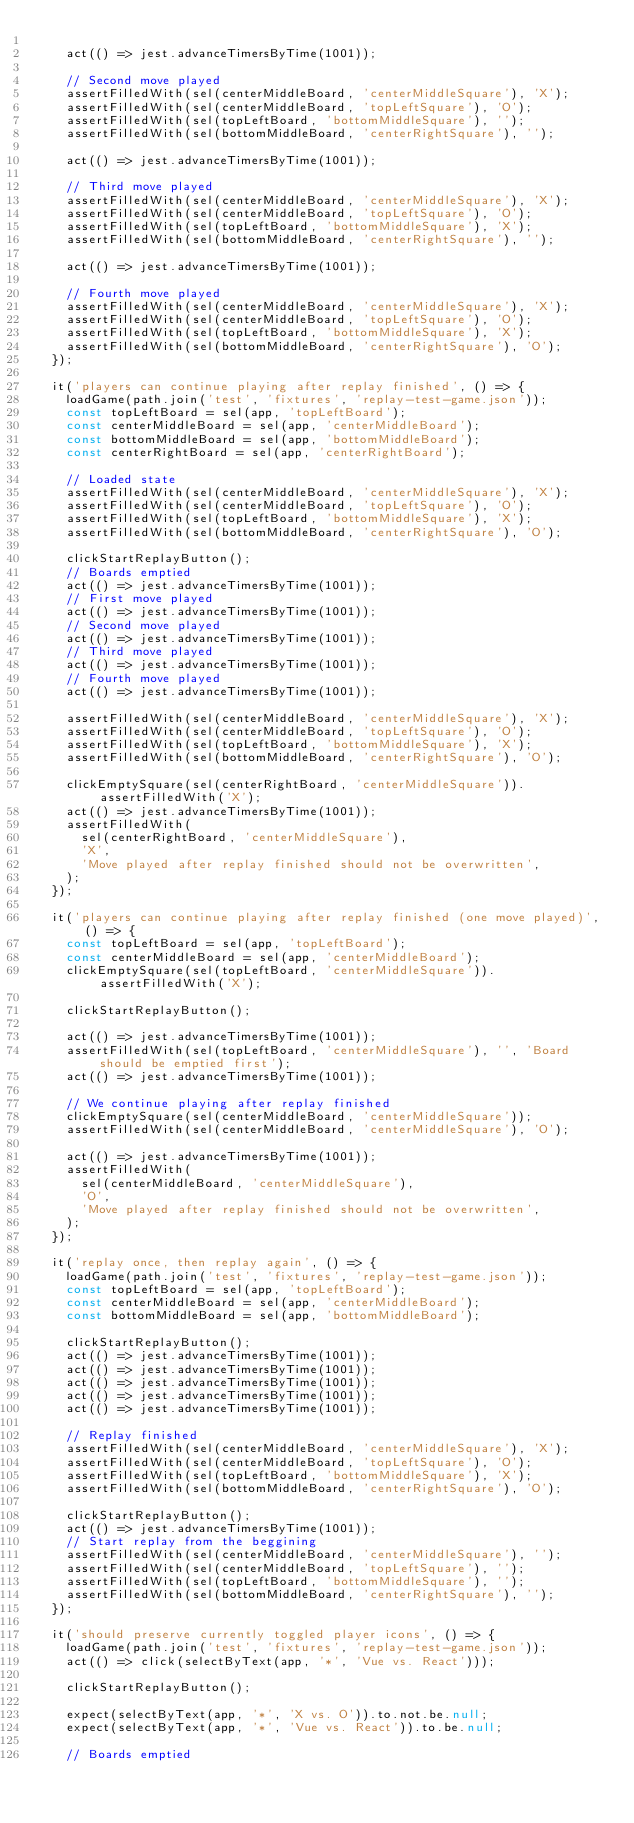<code> <loc_0><loc_0><loc_500><loc_500><_JavaScript_>
    act(() => jest.advanceTimersByTime(1001));

    // Second move played
    assertFilledWith(sel(centerMiddleBoard, 'centerMiddleSquare'), 'X');
    assertFilledWith(sel(centerMiddleBoard, 'topLeftSquare'), 'O');
    assertFilledWith(sel(topLeftBoard, 'bottomMiddleSquare'), '');
    assertFilledWith(sel(bottomMiddleBoard, 'centerRightSquare'), '');

    act(() => jest.advanceTimersByTime(1001));

    // Third move played
    assertFilledWith(sel(centerMiddleBoard, 'centerMiddleSquare'), 'X');
    assertFilledWith(sel(centerMiddleBoard, 'topLeftSquare'), 'O');
    assertFilledWith(sel(topLeftBoard, 'bottomMiddleSquare'), 'X');
    assertFilledWith(sel(bottomMiddleBoard, 'centerRightSquare'), '');

    act(() => jest.advanceTimersByTime(1001));

    // Fourth move played
    assertFilledWith(sel(centerMiddleBoard, 'centerMiddleSquare'), 'X');
    assertFilledWith(sel(centerMiddleBoard, 'topLeftSquare'), 'O');
    assertFilledWith(sel(topLeftBoard, 'bottomMiddleSquare'), 'X');
    assertFilledWith(sel(bottomMiddleBoard, 'centerRightSquare'), 'O');
  });

  it('players can continue playing after replay finished', () => {
    loadGame(path.join('test', 'fixtures', 'replay-test-game.json'));
    const topLeftBoard = sel(app, 'topLeftBoard');
    const centerMiddleBoard = sel(app, 'centerMiddleBoard');
    const bottomMiddleBoard = sel(app, 'bottomMiddleBoard');
    const centerRightBoard = sel(app, 'centerRightBoard');

    // Loaded state
    assertFilledWith(sel(centerMiddleBoard, 'centerMiddleSquare'), 'X');
    assertFilledWith(sel(centerMiddleBoard, 'topLeftSquare'), 'O');
    assertFilledWith(sel(topLeftBoard, 'bottomMiddleSquare'), 'X');
    assertFilledWith(sel(bottomMiddleBoard, 'centerRightSquare'), 'O');

    clickStartReplayButton();
    // Boards emptied
    act(() => jest.advanceTimersByTime(1001));
    // First move played
    act(() => jest.advanceTimersByTime(1001));
    // Second move played
    act(() => jest.advanceTimersByTime(1001));
    // Third move played
    act(() => jest.advanceTimersByTime(1001));
    // Fourth move played
    act(() => jest.advanceTimersByTime(1001));

    assertFilledWith(sel(centerMiddleBoard, 'centerMiddleSquare'), 'X');
    assertFilledWith(sel(centerMiddleBoard, 'topLeftSquare'), 'O');
    assertFilledWith(sel(topLeftBoard, 'bottomMiddleSquare'), 'X');
    assertFilledWith(sel(bottomMiddleBoard, 'centerRightSquare'), 'O');

    clickEmptySquare(sel(centerRightBoard, 'centerMiddleSquare')).assertFilledWith('X');
    act(() => jest.advanceTimersByTime(1001));
    assertFilledWith(
      sel(centerRightBoard, 'centerMiddleSquare'),
      'X',
      'Move played after replay finished should not be overwritten',
    );
  });

  it('players can continue playing after replay finished (one move played)', () => {
    const topLeftBoard = sel(app, 'topLeftBoard');
    const centerMiddleBoard = sel(app, 'centerMiddleBoard');
    clickEmptySquare(sel(topLeftBoard, 'centerMiddleSquare')).assertFilledWith('X');

    clickStartReplayButton();

    act(() => jest.advanceTimersByTime(1001));
    assertFilledWith(sel(topLeftBoard, 'centerMiddleSquare'), '', 'Board should be emptied first');
    act(() => jest.advanceTimersByTime(1001));

    // We continue playing after replay finished
    clickEmptySquare(sel(centerMiddleBoard, 'centerMiddleSquare'));
    assertFilledWith(sel(centerMiddleBoard, 'centerMiddleSquare'), 'O');

    act(() => jest.advanceTimersByTime(1001));
    assertFilledWith(
      sel(centerMiddleBoard, 'centerMiddleSquare'),
      'O',
      'Move played after replay finished should not be overwritten',
    );
  });

  it('replay once, then replay again', () => {
    loadGame(path.join('test', 'fixtures', 'replay-test-game.json'));
    const topLeftBoard = sel(app, 'topLeftBoard');
    const centerMiddleBoard = sel(app, 'centerMiddleBoard');
    const bottomMiddleBoard = sel(app, 'bottomMiddleBoard');

    clickStartReplayButton();
    act(() => jest.advanceTimersByTime(1001));
    act(() => jest.advanceTimersByTime(1001));
    act(() => jest.advanceTimersByTime(1001));
    act(() => jest.advanceTimersByTime(1001));
    act(() => jest.advanceTimersByTime(1001));

    // Replay finished
    assertFilledWith(sel(centerMiddleBoard, 'centerMiddleSquare'), 'X');
    assertFilledWith(sel(centerMiddleBoard, 'topLeftSquare'), 'O');
    assertFilledWith(sel(topLeftBoard, 'bottomMiddleSquare'), 'X');
    assertFilledWith(sel(bottomMiddleBoard, 'centerRightSquare'), 'O');

    clickStartReplayButton();
    act(() => jest.advanceTimersByTime(1001));
    // Start replay from the beggining
    assertFilledWith(sel(centerMiddleBoard, 'centerMiddleSquare'), '');
    assertFilledWith(sel(centerMiddleBoard, 'topLeftSquare'), '');
    assertFilledWith(sel(topLeftBoard, 'bottomMiddleSquare'), '');
    assertFilledWith(sel(bottomMiddleBoard, 'centerRightSquare'), '');
  });

  it('should preserve currently toggled player icons', () => {
    loadGame(path.join('test', 'fixtures', 'replay-test-game.json'));
    act(() => click(selectByText(app, '*', 'Vue vs. React')));

    clickStartReplayButton();

    expect(selectByText(app, '*', 'X vs. O')).to.not.be.null;
    expect(selectByText(app, '*', 'Vue vs. React')).to.be.null;

    // Boards emptied</code> 